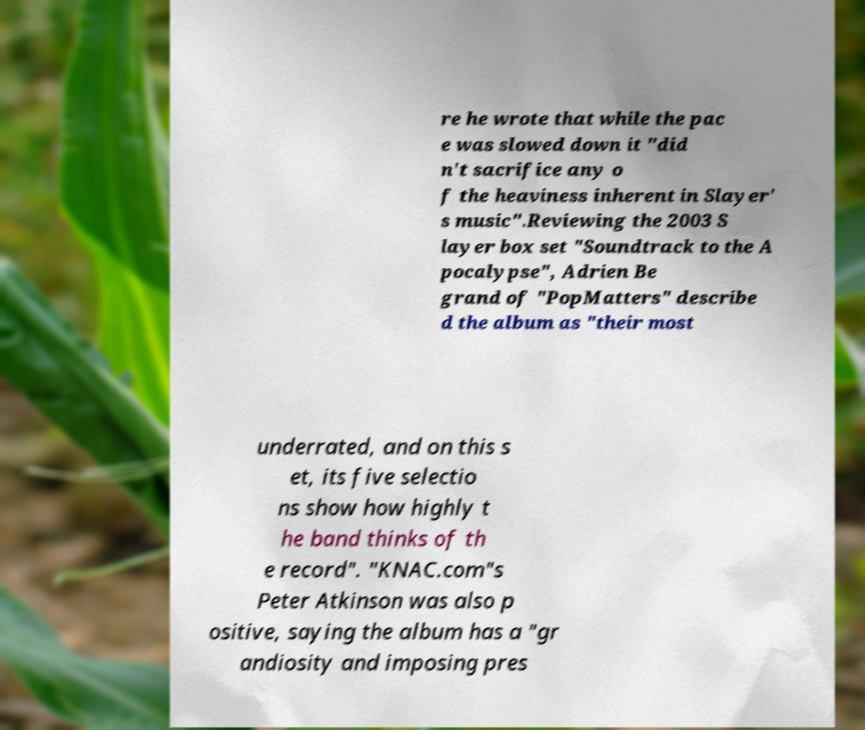For documentation purposes, I need the text within this image transcribed. Could you provide that? re he wrote that while the pac e was slowed down it "did n't sacrifice any o f the heaviness inherent in Slayer' s music".Reviewing the 2003 S layer box set "Soundtrack to the A pocalypse", Adrien Be grand of "PopMatters" describe d the album as "their most underrated, and on this s et, its five selectio ns show how highly t he band thinks of th e record". "KNAC.com"s Peter Atkinson was also p ositive, saying the album has a "gr andiosity and imposing pres 